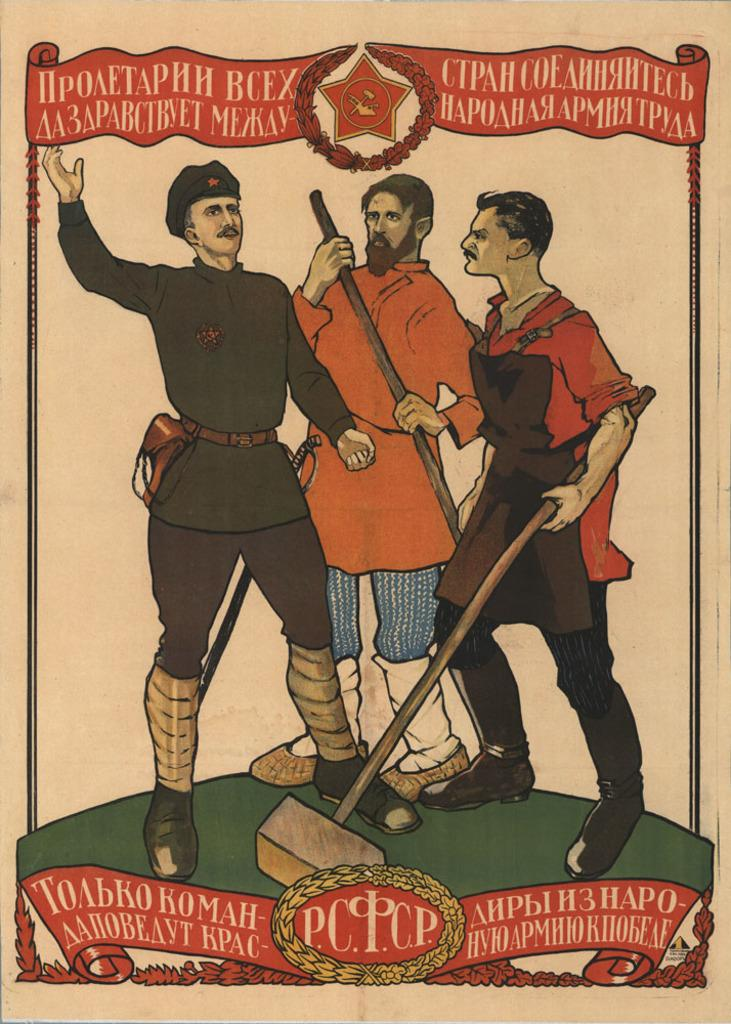What is featured in the image? There is a poster in the image. What is depicted on the poster? The poster depicts 3 men. What distinguishes each of the 3 men on the poster? Each of the 3 men has a different job. What is the setting of the poster? The men on the poster are standing on the ground. Can you see a giraffe or a hen in the image? No, there is no giraffe or hen present in the image. Is there a boat visible in the image? No, there is no boat visible in the image. 